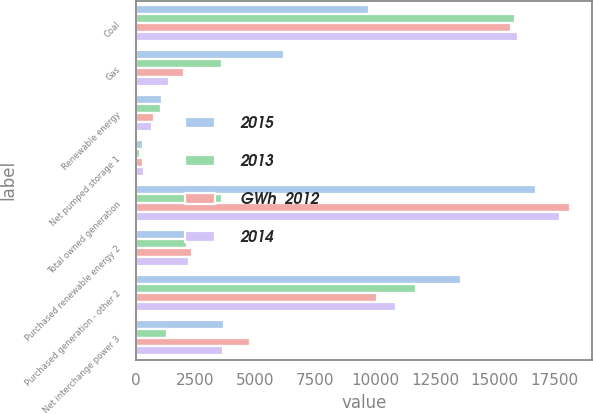Convert chart. <chart><loc_0><loc_0><loc_500><loc_500><stacked_bar_chart><ecel><fcel>Coal<fcel>Gas<fcel>Renewable energy<fcel>Net pumped storage 1<fcel>Total owned generation<fcel>Purchased renewable energy 2<fcel>Purchased generation - other 2<fcel>Net interchange power 3<nl><fcel>2015<fcel>9739<fcel>6194<fcel>1083<fcel>316<fcel>16708<fcel>2229<fcel>13578<fcel>3688<nl><fcel>2013<fcel>15833<fcel>3601<fcel>1056<fcel>186<fcel>3601<fcel>2163<fcel>11720<fcel>1327<nl><fcel>GWh  2012<fcel>15684<fcel>2012<fcel>748<fcel>300<fcel>18144<fcel>2366<fcel>10073<fcel>4793<nl><fcel>2014<fcel>15951<fcel>1415<fcel>704<fcel>371<fcel>17703<fcel>2250<fcel>10871<fcel>3656<nl></chart> 